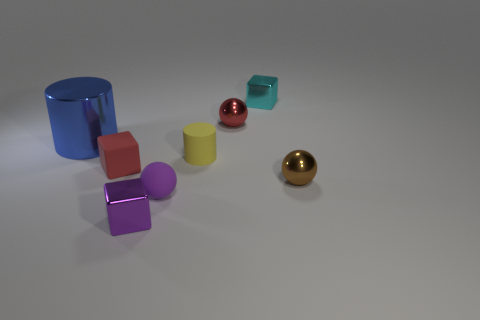There is a metallic block left of the cyan block; is it the same color as the small ball on the left side of the yellow matte thing?
Your response must be concise. Yes. Are the small block to the right of the yellow cylinder and the tiny yellow object made of the same material?
Offer a terse response. No. What material is the red thing that is the same shape as the small purple matte object?
Offer a very short reply. Metal. What is the material of the big thing?
Provide a short and direct response. Metal. There is a metallic cube that is behind the blue cylinder; does it have the same size as the small brown shiny thing?
Make the answer very short. Yes. What is the size of the shiny thing on the left side of the purple shiny block?
Your response must be concise. Large. What number of tiny purple rubber balls are there?
Make the answer very short. 1. What color is the metal thing that is both behind the yellow matte cylinder and left of the tiny purple matte object?
Your answer should be compact. Blue. There is a big blue thing; are there any small purple metallic objects in front of it?
Keep it short and to the point. Yes. What number of big blue cylinders are in front of the small metallic object to the right of the cyan cube?
Offer a terse response. 0. 